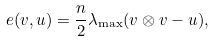<formula> <loc_0><loc_0><loc_500><loc_500>e ( v , u ) = \frac { n } { 2 } \lambda _ { \max } ( v \otimes v - u ) ,</formula> 